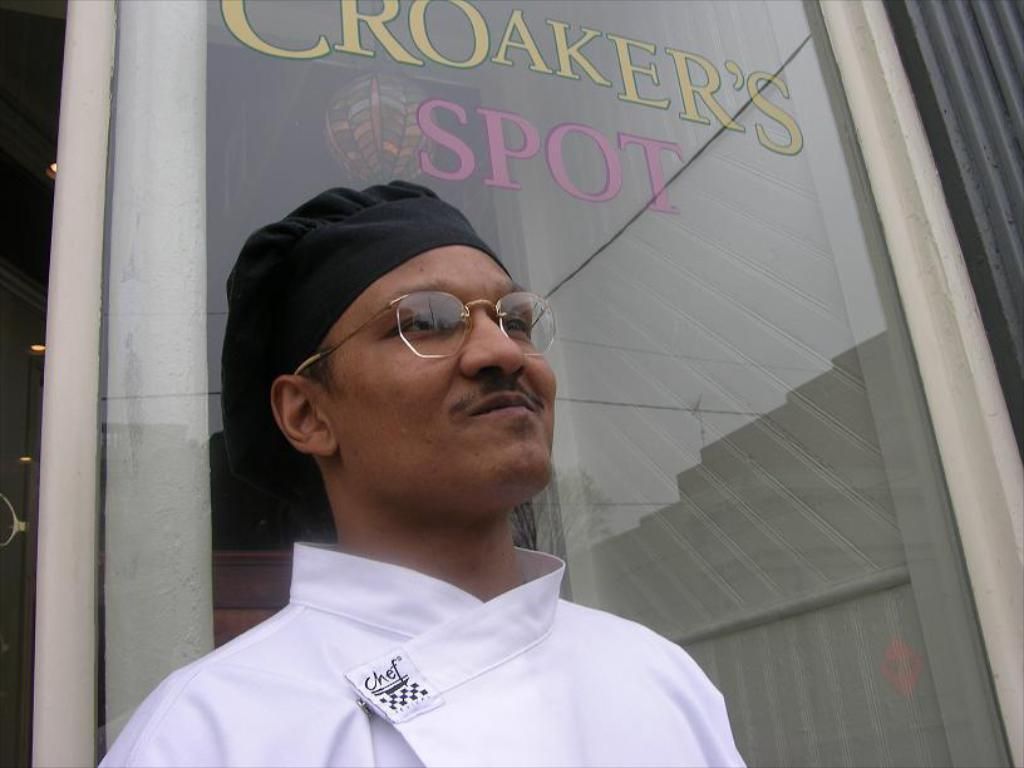What is the main subject in the foreground of the image? There is a person in the foreground of the image. Can you describe the person's appearance? The person is wearing spectacles and a cap. What can be seen in the background of the image? There is a glass door, a ball, and lights in the background of the image. What is written on the glass door? The glass door has some text on it. What type of heat can be felt coming from the page in the image? There is no page present in the image, so it is not possible to determine if any heat can be felt. 